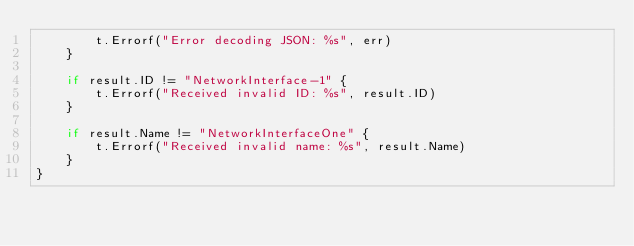<code> <loc_0><loc_0><loc_500><loc_500><_Go_>		t.Errorf("Error decoding JSON: %s", err)
	}

	if result.ID != "NetworkInterface-1" {
		t.Errorf("Received invalid ID: %s", result.ID)
	}

	if result.Name != "NetworkInterfaceOne" {
		t.Errorf("Received invalid name: %s", result.Name)
	}
}
</code> 